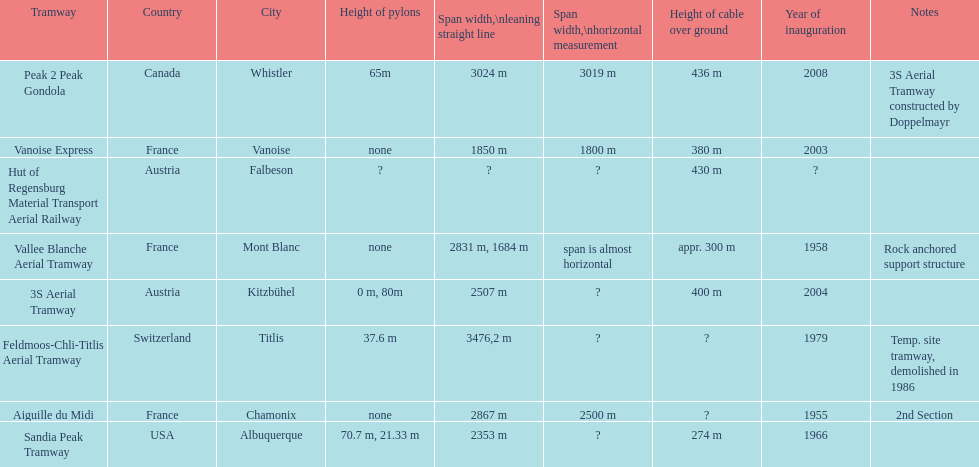How much longer is the peak 2 peak gondola than the 32 aerial tramway? 517. 